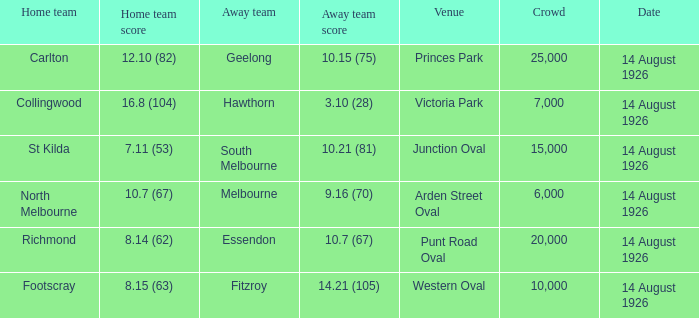What was the size of the largest crowd that Essendon played in front of as the away team? 20000.0. 